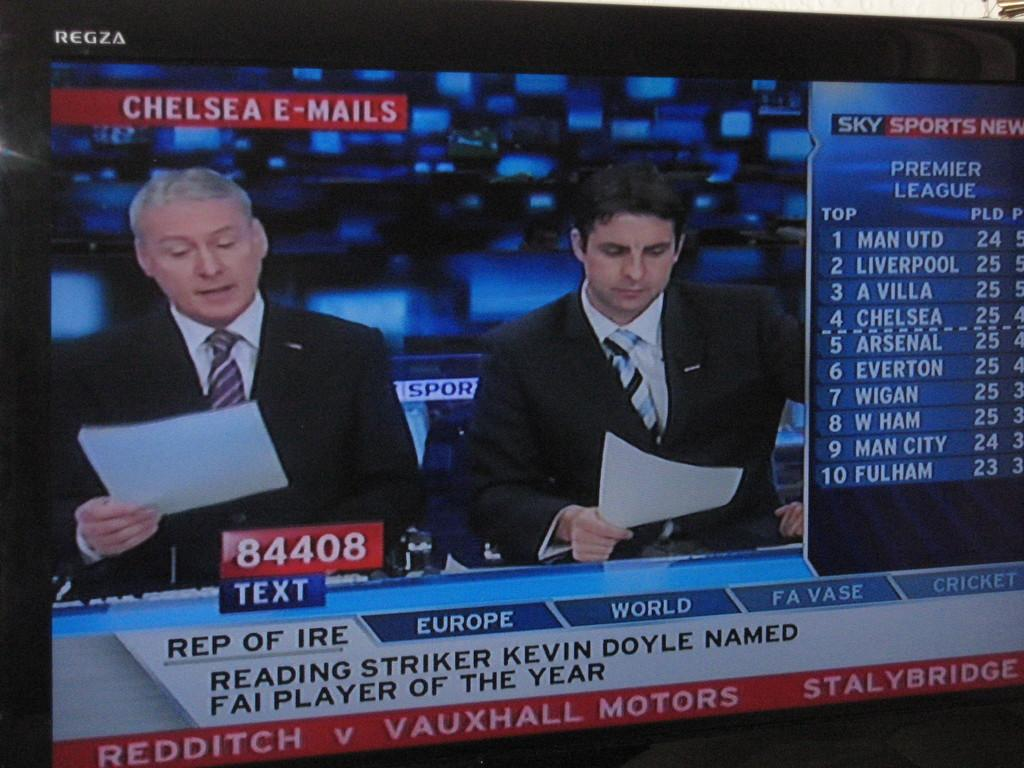<image>
Relay a brief, clear account of the picture shown. A news show on the country of Europe is on television. 